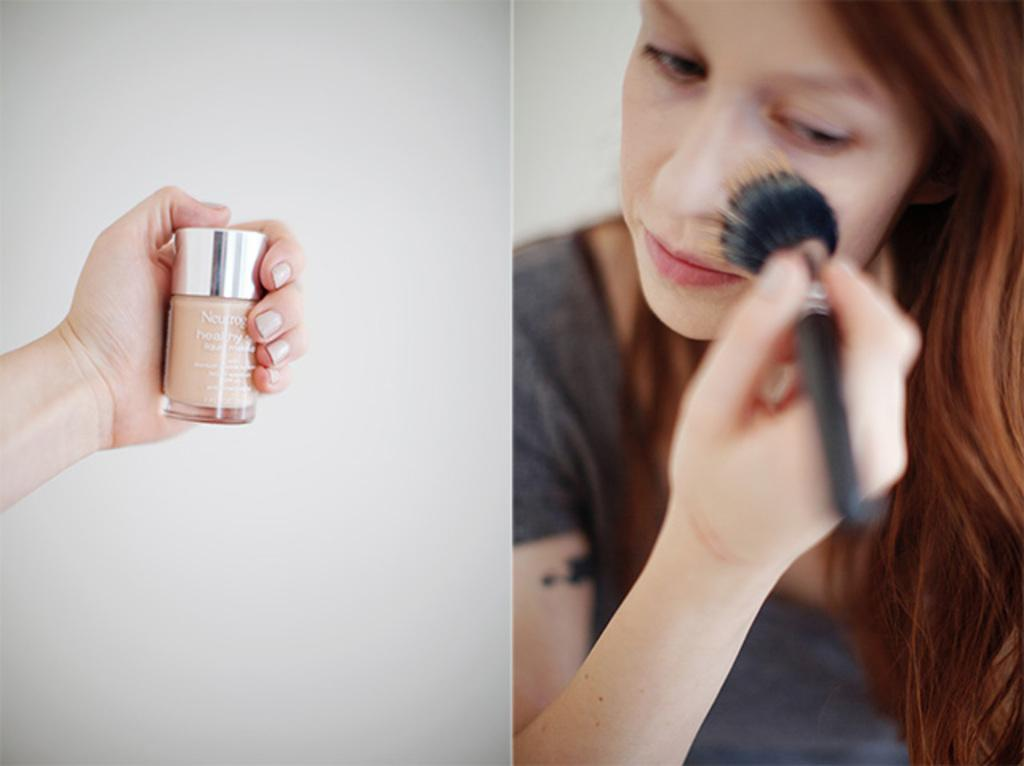How many images are combined in the collage? The image is a collage of two images. What is the person's hand holding in the left image? In the left image, there is a person's hand holding a bottle. What is the woman holding in the right image? In the right image, there is a woman holding a make-up brush. What type of cave can be seen in the background of the image? There is no cave present in the image; it is a collage of two images featuring a hand holding a bottle and a woman holding a make-up brush. How does the cap on the bottle affect the woman's respect for the make-up brush? The cap on the bottle does not affect the woman's respect for the make-up brush, as there is no interaction between the two objects in the image. 